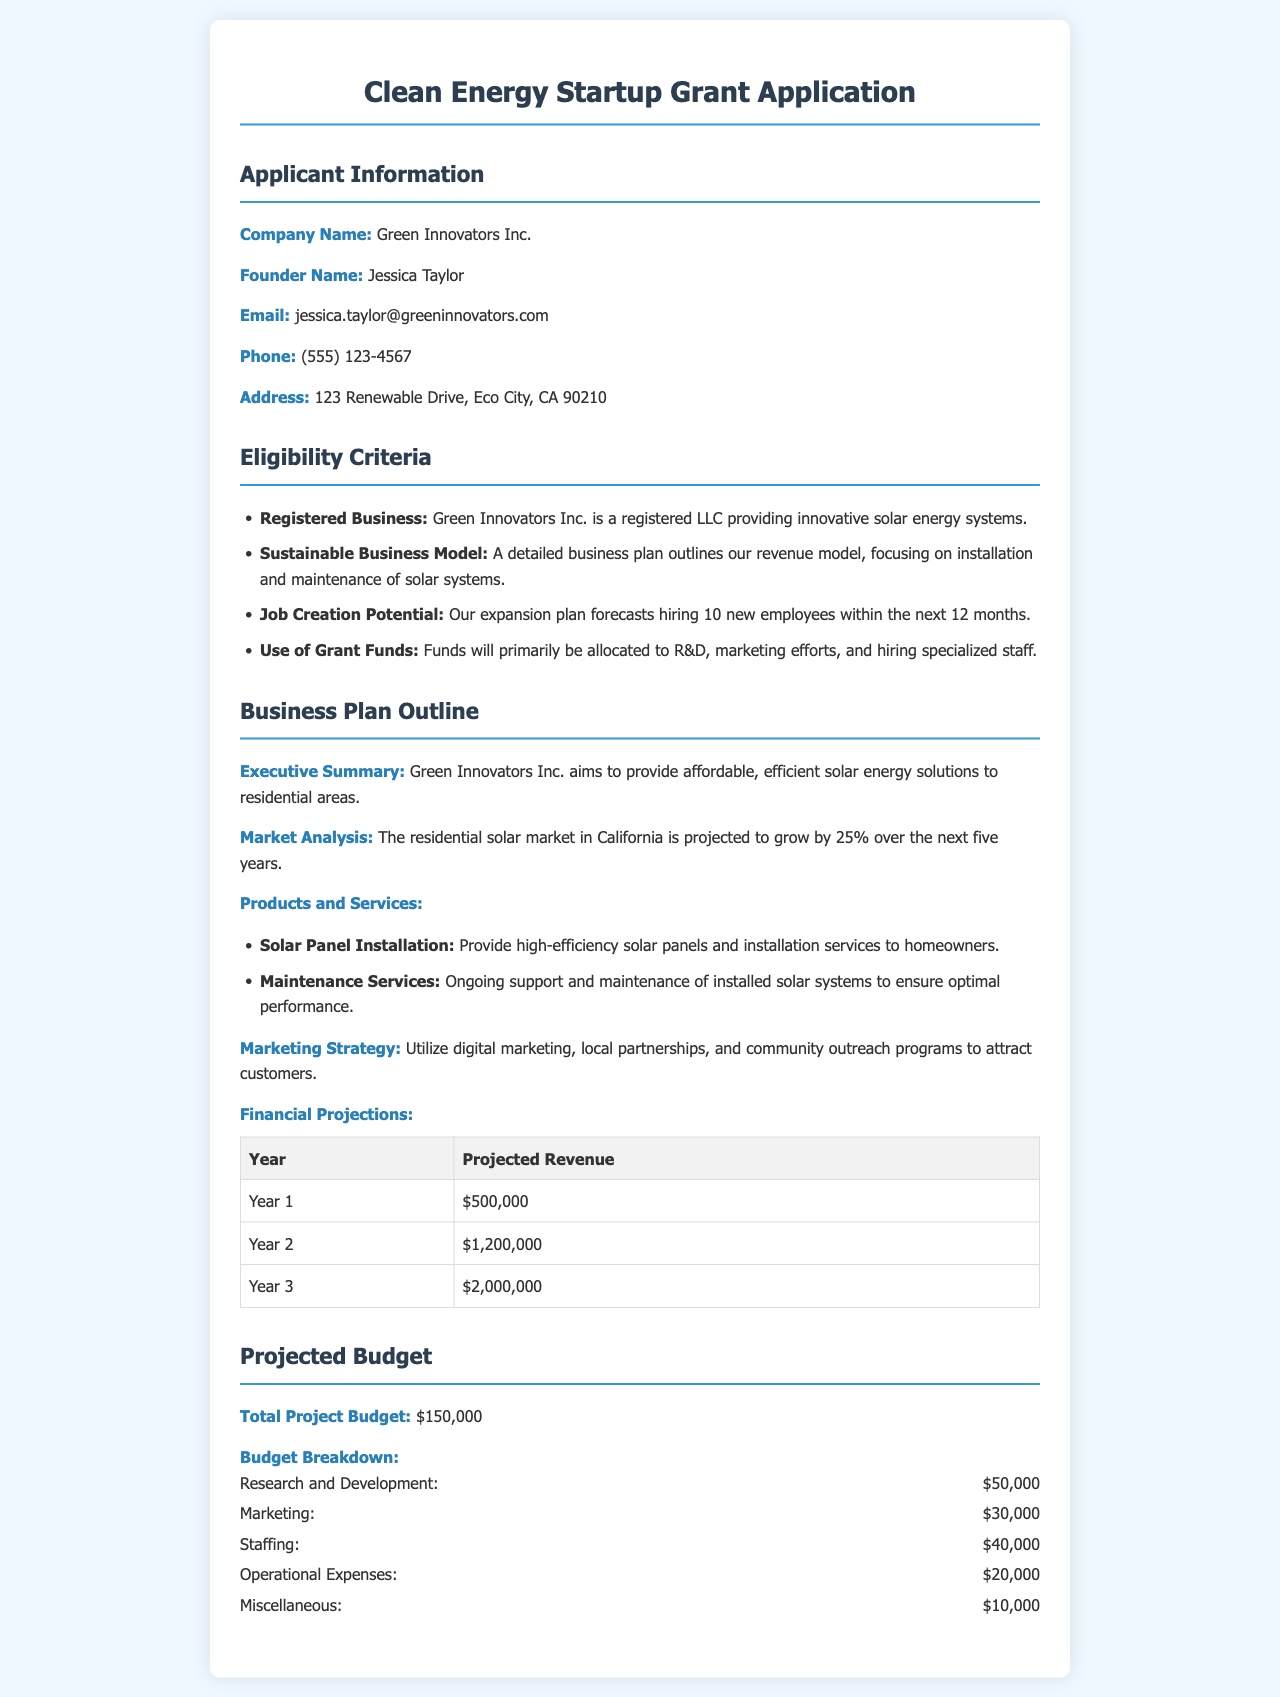What is the company name? The company name is provided in the applicant information section of the document.
Answer: Green Innovators Inc Who is the founder? The founder's name is listed under the applicant information section.
Answer: Jessica Taylor What is the projected revenue for Year 2? The projected revenue for Year 2 is found in the financial projections table.
Answer: $1,200,000 How many new employees does the expansion plan forecast hiring? The estimated number of new employees is mentioned in the eligibility criteria section.
Answer: 10 What percentage is the residential solar market projected to grow in the next five years? The growth percentage for the residential solar market is indicated in the market analysis section.
Answer: 25% What is the total project budget? The total project budget is stated in the projected budget section.
Answer: $150,000 What percentage of the budget is allocated to Research and Development? The budget for Research and Development is mentioned in the budget breakdown.
Answer: $50,000 What type of business model does Green Innovators Inc. have? The nature of the business model is outlined in the eligibility criteria section.
Answer: Sustainable Business Model 